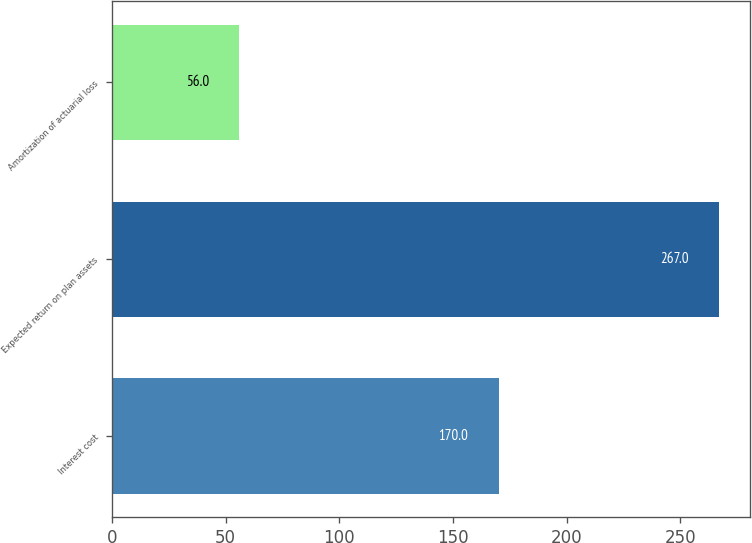Convert chart. <chart><loc_0><loc_0><loc_500><loc_500><bar_chart><fcel>Interest cost<fcel>Expected return on plan assets<fcel>Amortization of actuarial loss<nl><fcel>170<fcel>267<fcel>56<nl></chart> 